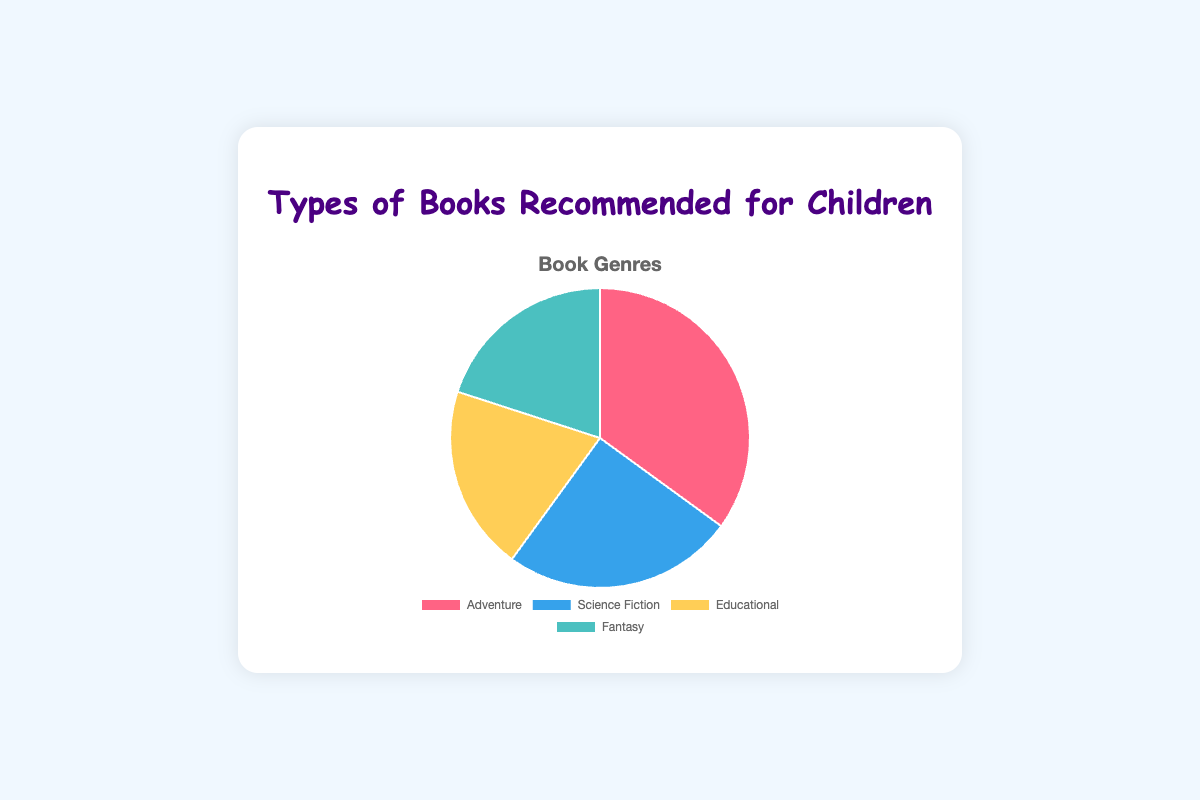Which book genre has the highest recommendation percentage? The pie chart shows that Adventure books make up the largest portion, which is 35%.
Answer: Adventure How much higher is the recommendation percentage for Adventure books than for Fantasy books? The recommendation percentage for Adventure is 35%, while for Fantasy it is 20%. The difference is 35% - 20% = 15%.
Answer: 15% Are the recommendation percentages for Science Fiction and Fantasy books the same? Observing the pie chart, both Science Fiction and Fantasy books have a recommendation percentage of 20%.
Answer: Yes What is the total percentage of recommendations for Educational and Fantasy books combined? The recommendation percentages for Educational and Fantasy books are both 20%. Summing them up gives 20% + 20% = 40%.
Answer: 40% Which color represents the Science Fiction genre in the pie chart? The Science Fiction segment is colored blue as indicated in the chart's legend.
Answer: Blue What is the smallest segment in the pie chart, and what does it represent? The smallest segments are those for Educational and Fantasy books, both representing 20%.
Answer: Educational and Fantasy How do the recommendation percentages for Science Fiction and Educational books compare? The recommendation percentage for Science Fiction is 25%, while for Educational it's 20%. Science Fiction is higher by 5%.
Answer: 5% How many genres have an equal recommendation percentage? The pie chart shows that two genres, Educational and Fantasy, both have a recommendation percentage of 20%.
Answer: Two Combine the percentages of Adventure, Science Fiction, and Educational genres. What is the total? The recommendation percentages for Adventure, Science Fiction, and Educational are 35%, 25%, and 20% respectively. Summing them gives 35% + 25% + 20% = 80%.
Answer: 80% Which genre occupies the red segment in the pie chart? The legend indicates that the red segment represents Adventure books.
Answer: Adventure 